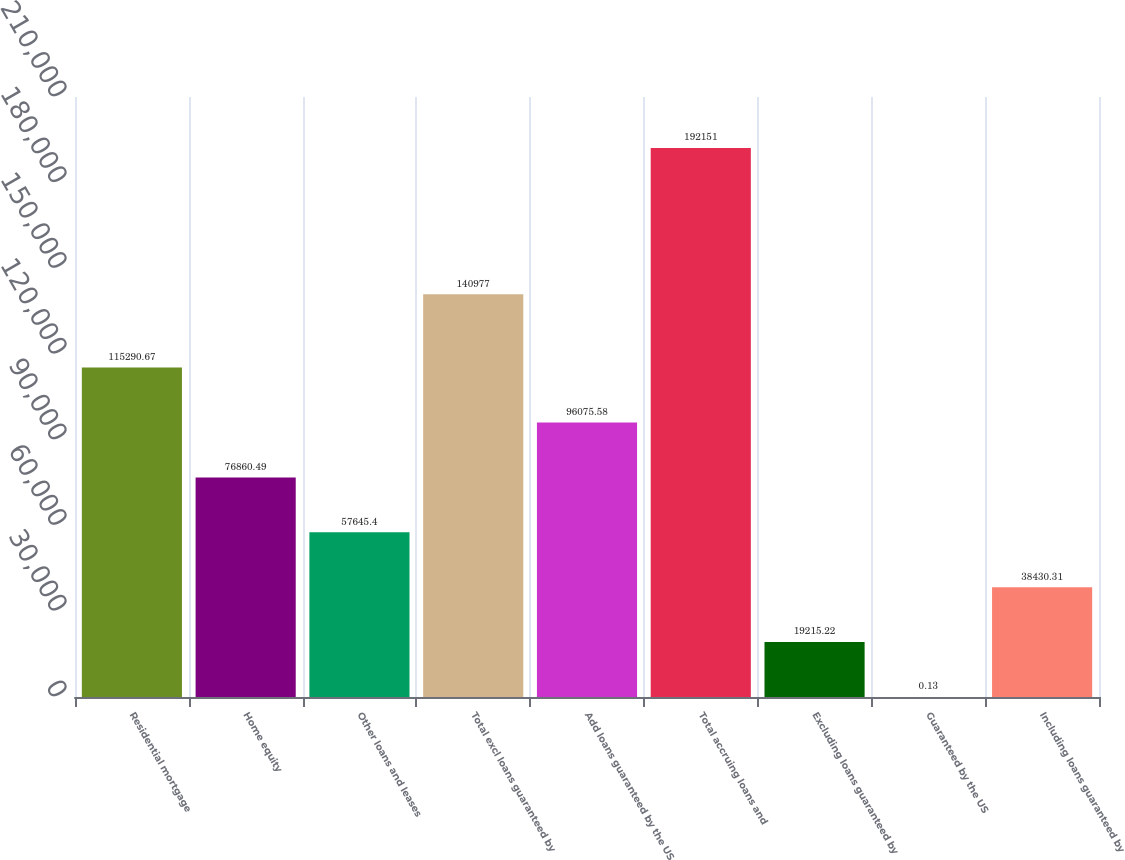Convert chart to OTSL. <chart><loc_0><loc_0><loc_500><loc_500><bar_chart><fcel>Residential mortgage<fcel>Home equity<fcel>Other loans and leases<fcel>Total excl loans guaranteed by<fcel>Add loans guaranteed by the US<fcel>Total accruing loans and<fcel>Excluding loans guaranteed by<fcel>Guaranteed by the US<fcel>Including loans guaranteed by<nl><fcel>115291<fcel>76860.5<fcel>57645.4<fcel>140977<fcel>96075.6<fcel>192151<fcel>19215.2<fcel>0.13<fcel>38430.3<nl></chart> 